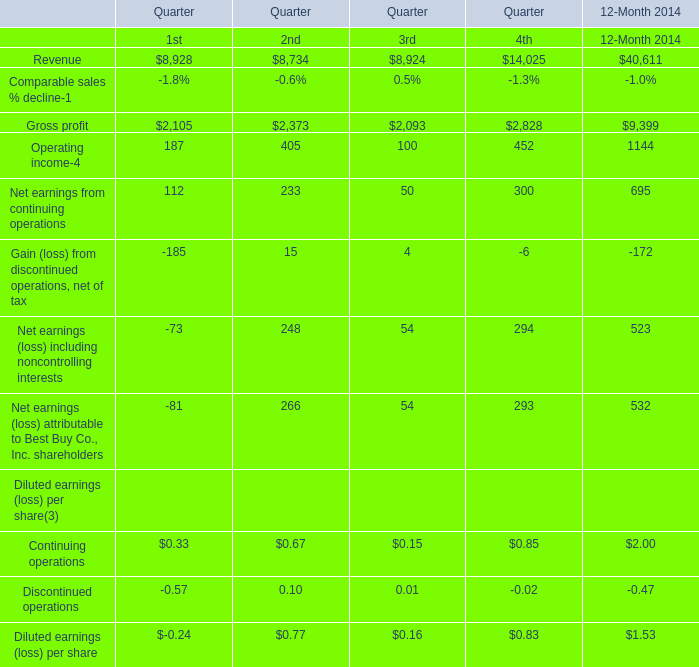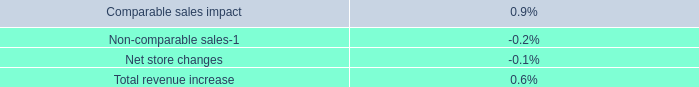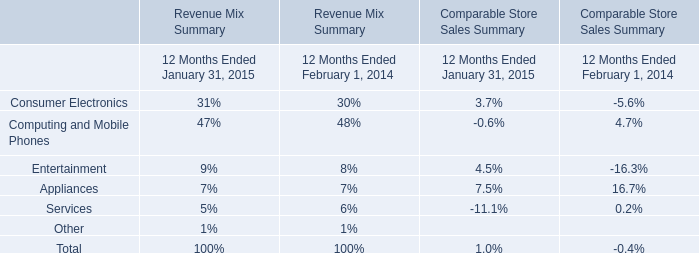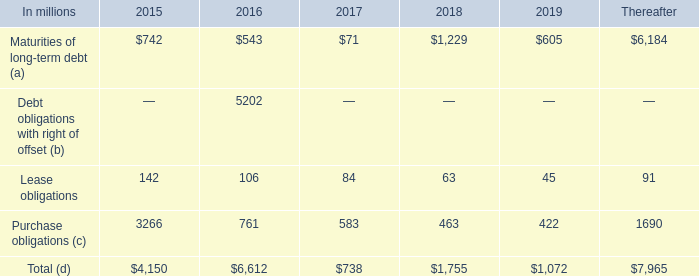What's the average of the revenue in the years where gross profit is positive? 
Computations: (40611 / 1)
Answer: 40611.0. 